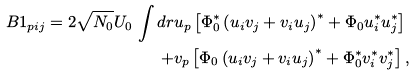Convert formula to latex. <formula><loc_0><loc_0><loc_500><loc_500>B 1 _ { p i j } = 2 \sqrt { N _ { 0 } } U _ { 0 } \, \int d r & u _ { p } \left [ \Phi _ { 0 } ^ { * } \left ( u _ { i } v _ { j } + v _ { i } u _ { j } \right ) ^ { * } + \Phi _ { 0 } u _ { i } ^ { * } u _ { j } ^ { * } \right ] \\ + & v _ { p } \left [ \Phi _ { 0 } \left ( u _ { i } v _ { j } + v _ { i } u _ { j } \right ) ^ { * } + \Phi _ { 0 } ^ { * } v _ { i } ^ { * } v _ { j } ^ { * } \right ] ,</formula> 